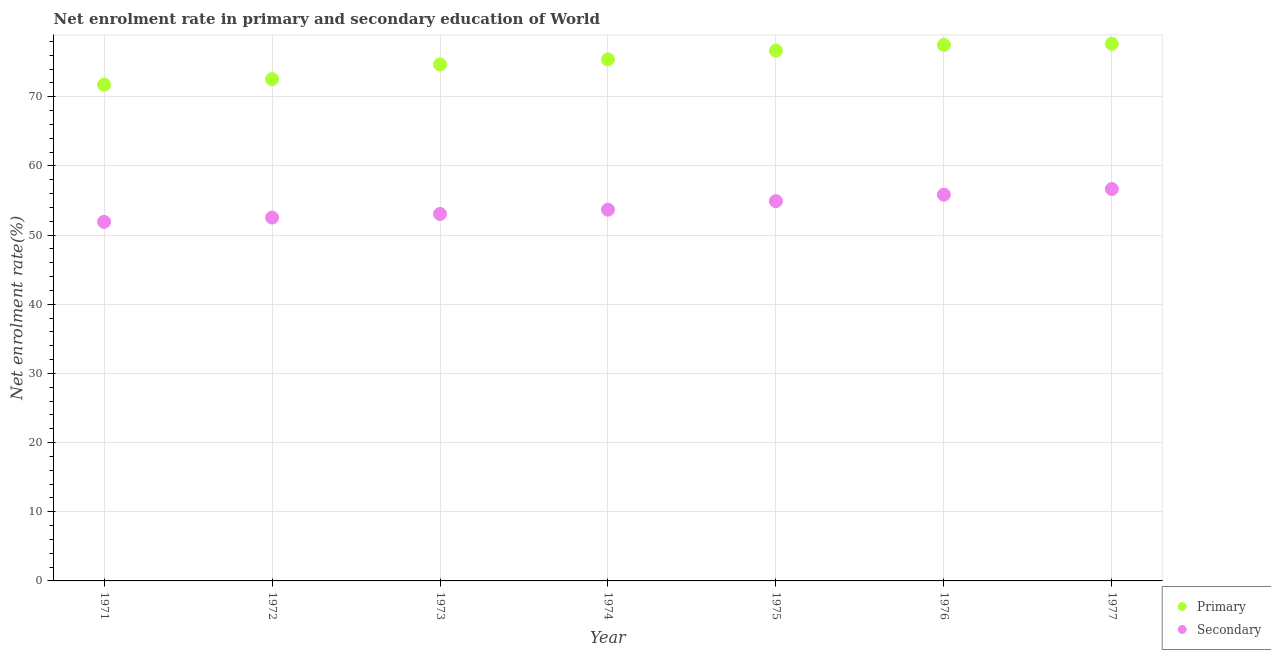Is the number of dotlines equal to the number of legend labels?
Offer a very short reply. Yes. What is the enrollment rate in secondary education in 1975?
Give a very brief answer. 54.9. Across all years, what is the maximum enrollment rate in primary education?
Your answer should be compact. 77.65. Across all years, what is the minimum enrollment rate in primary education?
Ensure brevity in your answer.  71.73. In which year was the enrollment rate in secondary education maximum?
Your response must be concise. 1977. In which year was the enrollment rate in secondary education minimum?
Make the answer very short. 1971. What is the total enrollment rate in primary education in the graph?
Provide a succinct answer. 526.11. What is the difference between the enrollment rate in secondary education in 1976 and that in 1977?
Provide a succinct answer. -0.82. What is the difference between the enrollment rate in secondary education in 1972 and the enrollment rate in primary education in 1974?
Ensure brevity in your answer.  -22.87. What is the average enrollment rate in primary education per year?
Offer a very short reply. 75.16. In the year 1977, what is the difference between the enrollment rate in primary education and enrollment rate in secondary education?
Provide a short and direct response. 21. What is the ratio of the enrollment rate in primary education in 1971 to that in 1977?
Ensure brevity in your answer.  0.92. Is the enrollment rate in secondary education in 1972 less than that in 1974?
Your answer should be very brief. Yes. Is the difference between the enrollment rate in secondary education in 1972 and 1975 greater than the difference between the enrollment rate in primary education in 1972 and 1975?
Make the answer very short. Yes. What is the difference between the highest and the second highest enrollment rate in primary education?
Give a very brief answer. 0.17. What is the difference between the highest and the lowest enrollment rate in secondary education?
Offer a very short reply. 4.74. In how many years, is the enrollment rate in secondary education greater than the average enrollment rate in secondary education taken over all years?
Make the answer very short. 3. Is the sum of the enrollment rate in primary education in 1972 and 1976 greater than the maximum enrollment rate in secondary education across all years?
Provide a succinct answer. Yes. Does the enrollment rate in secondary education monotonically increase over the years?
Keep it short and to the point. Yes. Is the enrollment rate in primary education strictly greater than the enrollment rate in secondary education over the years?
Ensure brevity in your answer.  Yes. Does the graph contain any zero values?
Your answer should be very brief. No. Does the graph contain grids?
Your response must be concise. Yes. How are the legend labels stacked?
Your answer should be very brief. Vertical. What is the title of the graph?
Give a very brief answer. Net enrolment rate in primary and secondary education of World. Does "Constant 2005 US$" appear as one of the legend labels in the graph?
Give a very brief answer. No. What is the label or title of the Y-axis?
Give a very brief answer. Net enrolment rate(%). What is the Net enrolment rate(%) of Primary in 1971?
Provide a succinct answer. 71.73. What is the Net enrolment rate(%) in Secondary in 1971?
Provide a succinct answer. 51.91. What is the Net enrolment rate(%) of Primary in 1972?
Provide a short and direct response. 72.54. What is the Net enrolment rate(%) in Secondary in 1972?
Ensure brevity in your answer.  52.52. What is the Net enrolment rate(%) in Primary in 1973?
Offer a terse response. 74.66. What is the Net enrolment rate(%) of Secondary in 1973?
Give a very brief answer. 53.05. What is the Net enrolment rate(%) of Primary in 1974?
Your answer should be compact. 75.39. What is the Net enrolment rate(%) of Secondary in 1974?
Make the answer very short. 53.67. What is the Net enrolment rate(%) in Primary in 1975?
Give a very brief answer. 76.66. What is the Net enrolment rate(%) of Secondary in 1975?
Provide a succinct answer. 54.9. What is the Net enrolment rate(%) of Primary in 1976?
Your answer should be very brief. 77.48. What is the Net enrolment rate(%) of Secondary in 1976?
Offer a terse response. 55.83. What is the Net enrolment rate(%) in Primary in 1977?
Provide a short and direct response. 77.65. What is the Net enrolment rate(%) in Secondary in 1977?
Offer a very short reply. 56.65. Across all years, what is the maximum Net enrolment rate(%) of Primary?
Offer a very short reply. 77.65. Across all years, what is the maximum Net enrolment rate(%) of Secondary?
Your answer should be compact. 56.65. Across all years, what is the minimum Net enrolment rate(%) of Primary?
Offer a very short reply. 71.73. Across all years, what is the minimum Net enrolment rate(%) in Secondary?
Give a very brief answer. 51.91. What is the total Net enrolment rate(%) of Primary in the graph?
Offer a terse response. 526.11. What is the total Net enrolment rate(%) of Secondary in the graph?
Your response must be concise. 378.53. What is the difference between the Net enrolment rate(%) of Primary in 1971 and that in 1972?
Keep it short and to the point. -0.81. What is the difference between the Net enrolment rate(%) of Secondary in 1971 and that in 1972?
Provide a succinct answer. -0.62. What is the difference between the Net enrolment rate(%) in Primary in 1971 and that in 1973?
Ensure brevity in your answer.  -2.93. What is the difference between the Net enrolment rate(%) of Secondary in 1971 and that in 1973?
Provide a succinct answer. -1.14. What is the difference between the Net enrolment rate(%) of Primary in 1971 and that in 1974?
Provide a short and direct response. -3.66. What is the difference between the Net enrolment rate(%) of Secondary in 1971 and that in 1974?
Offer a terse response. -1.76. What is the difference between the Net enrolment rate(%) in Primary in 1971 and that in 1975?
Your response must be concise. -4.93. What is the difference between the Net enrolment rate(%) in Secondary in 1971 and that in 1975?
Your answer should be very brief. -2.99. What is the difference between the Net enrolment rate(%) of Primary in 1971 and that in 1976?
Your response must be concise. -5.75. What is the difference between the Net enrolment rate(%) in Secondary in 1971 and that in 1976?
Your answer should be compact. -3.92. What is the difference between the Net enrolment rate(%) in Primary in 1971 and that in 1977?
Your answer should be compact. -5.92. What is the difference between the Net enrolment rate(%) in Secondary in 1971 and that in 1977?
Keep it short and to the point. -4.74. What is the difference between the Net enrolment rate(%) of Primary in 1972 and that in 1973?
Offer a terse response. -2.12. What is the difference between the Net enrolment rate(%) in Secondary in 1972 and that in 1973?
Offer a very short reply. -0.52. What is the difference between the Net enrolment rate(%) of Primary in 1972 and that in 1974?
Make the answer very short. -2.85. What is the difference between the Net enrolment rate(%) in Secondary in 1972 and that in 1974?
Your answer should be compact. -1.14. What is the difference between the Net enrolment rate(%) in Primary in 1972 and that in 1975?
Give a very brief answer. -4.12. What is the difference between the Net enrolment rate(%) in Secondary in 1972 and that in 1975?
Your answer should be very brief. -2.37. What is the difference between the Net enrolment rate(%) in Primary in 1972 and that in 1976?
Keep it short and to the point. -4.95. What is the difference between the Net enrolment rate(%) of Secondary in 1972 and that in 1976?
Give a very brief answer. -3.31. What is the difference between the Net enrolment rate(%) of Primary in 1972 and that in 1977?
Your response must be concise. -5.11. What is the difference between the Net enrolment rate(%) of Secondary in 1972 and that in 1977?
Provide a succinct answer. -4.13. What is the difference between the Net enrolment rate(%) in Primary in 1973 and that in 1974?
Give a very brief answer. -0.73. What is the difference between the Net enrolment rate(%) in Secondary in 1973 and that in 1974?
Offer a terse response. -0.62. What is the difference between the Net enrolment rate(%) of Primary in 1973 and that in 1975?
Offer a terse response. -2. What is the difference between the Net enrolment rate(%) of Secondary in 1973 and that in 1975?
Provide a short and direct response. -1.85. What is the difference between the Net enrolment rate(%) in Primary in 1973 and that in 1976?
Your answer should be compact. -2.82. What is the difference between the Net enrolment rate(%) of Secondary in 1973 and that in 1976?
Your answer should be compact. -2.78. What is the difference between the Net enrolment rate(%) in Primary in 1973 and that in 1977?
Offer a very short reply. -2.99. What is the difference between the Net enrolment rate(%) of Secondary in 1973 and that in 1977?
Provide a succinct answer. -3.6. What is the difference between the Net enrolment rate(%) of Primary in 1974 and that in 1975?
Offer a terse response. -1.27. What is the difference between the Net enrolment rate(%) in Secondary in 1974 and that in 1975?
Offer a terse response. -1.23. What is the difference between the Net enrolment rate(%) of Primary in 1974 and that in 1976?
Your response must be concise. -2.09. What is the difference between the Net enrolment rate(%) in Secondary in 1974 and that in 1976?
Offer a very short reply. -2.16. What is the difference between the Net enrolment rate(%) of Primary in 1974 and that in 1977?
Ensure brevity in your answer.  -2.26. What is the difference between the Net enrolment rate(%) in Secondary in 1974 and that in 1977?
Make the answer very short. -2.98. What is the difference between the Net enrolment rate(%) in Primary in 1975 and that in 1976?
Offer a very short reply. -0.82. What is the difference between the Net enrolment rate(%) of Secondary in 1975 and that in 1976?
Your answer should be compact. -0.93. What is the difference between the Net enrolment rate(%) in Primary in 1975 and that in 1977?
Provide a succinct answer. -0.99. What is the difference between the Net enrolment rate(%) of Secondary in 1975 and that in 1977?
Provide a short and direct response. -1.75. What is the difference between the Net enrolment rate(%) in Primary in 1976 and that in 1977?
Ensure brevity in your answer.  -0.17. What is the difference between the Net enrolment rate(%) in Secondary in 1976 and that in 1977?
Your answer should be compact. -0.82. What is the difference between the Net enrolment rate(%) in Primary in 1971 and the Net enrolment rate(%) in Secondary in 1972?
Offer a very short reply. 19.21. What is the difference between the Net enrolment rate(%) of Primary in 1971 and the Net enrolment rate(%) of Secondary in 1973?
Offer a terse response. 18.68. What is the difference between the Net enrolment rate(%) of Primary in 1971 and the Net enrolment rate(%) of Secondary in 1974?
Your answer should be compact. 18.06. What is the difference between the Net enrolment rate(%) in Primary in 1971 and the Net enrolment rate(%) in Secondary in 1975?
Keep it short and to the point. 16.83. What is the difference between the Net enrolment rate(%) of Primary in 1971 and the Net enrolment rate(%) of Secondary in 1976?
Your response must be concise. 15.9. What is the difference between the Net enrolment rate(%) of Primary in 1971 and the Net enrolment rate(%) of Secondary in 1977?
Offer a terse response. 15.08. What is the difference between the Net enrolment rate(%) in Primary in 1972 and the Net enrolment rate(%) in Secondary in 1973?
Your response must be concise. 19.49. What is the difference between the Net enrolment rate(%) of Primary in 1972 and the Net enrolment rate(%) of Secondary in 1974?
Make the answer very short. 18.87. What is the difference between the Net enrolment rate(%) in Primary in 1972 and the Net enrolment rate(%) in Secondary in 1975?
Keep it short and to the point. 17.64. What is the difference between the Net enrolment rate(%) in Primary in 1972 and the Net enrolment rate(%) in Secondary in 1976?
Offer a terse response. 16.71. What is the difference between the Net enrolment rate(%) of Primary in 1972 and the Net enrolment rate(%) of Secondary in 1977?
Provide a succinct answer. 15.89. What is the difference between the Net enrolment rate(%) in Primary in 1973 and the Net enrolment rate(%) in Secondary in 1974?
Provide a short and direct response. 20.99. What is the difference between the Net enrolment rate(%) in Primary in 1973 and the Net enrolment rate(%) in Secondary in 1975?
Your response must be concise. 19.76. What is the difference between the Net enrolment rate(%) of Primary in 1973 and the Net enrolment rate(%) of Secondary in 1976?
Your answer should be compact. 18.83. What is the difference between the Net enrolment rate(%) in Primary in 1973 and the Net enrolment rate(%) in Secondary in 1977?
Provide a succinct answer. 18.01. What is the difference between the Net enrolment rate(%) of Primary in 1974 and the Net enrolment rate(%) of Secondary in 1975?
Make the answer very short. 20.49. What is the difference between the Net enrolment rate(%) of Primary in 1974 and the Net enrolment rate(%) of Secondary in 1976?
Keep it short and to the point. 19.56. What is the difference between the Net enrolment rate(%) in Primary in 1974 and the Net enrolment rate(%) in Secondary in 1977?
Keep it short and to the point. 18.74. What is the difference between the Net enrolment rate(%) of Primary in 1975 and the Net enrolment rate(%) of Secondary in 1976?
Keep it short and to the point. 20.83. What is the difference between the Net enrolment rate(%) in Primary in 1975 and the Net enrolment rate(%) in Secondary in 1977?
Keep it short and to the point. 20.01. What is the difference between the Net enrolment rate(%) in Primary in 1976 and the Net enrolment rate(%) in Secondary in 1977?
Offer a very short reply. 20.83. What is the average Net enrolment rate(%) in Primary per year?
Make the answer very short. 75.16. What is the average Net enrolment rate(%) in Secondary per year?
Provide a succinct answer. 54.08. In the year 1971, what is the difference between the Net enrolment rate(%) of Primary and Net enrolment rate(%) of Secondary?
Your answer should be very brief. 19.82. In the year 1972, what is the difference between the Net enrolment rate(%) in Primary and Net enrolment rate(%) in Secondary?
Your answer should be compact. 20.01. In the year 1973, what is the difference between the Net enrolment rate(%) of Primary and Net enrolment rate(%) of Secondary?
Offer a very short reply. 21.61. In the year 1974, what is the difference between the Net enrolment rate(%) of Primary and Net enrolment rate(%) of Secondary?
Make the answer very short. 21.72. In the year 1975, what is the difference between the Net enrolment rate(%) in Primary and Net enrolment rate(%) in Secondary?
Your response must be concise. 21.76. In the year 1976, what is the difference between the Net enrolment rate(%) of Primary and Net enrolment rate(%) of Secondary?
Your response must be concise. 21.65. In the year 1977, what is the difference between the Net enrolment rate(%) of Primary and Net enrolment rate(%) of Secondary?
Your answer should be compact. 21. What is the ratio of the Net enrolment rate(%) in Primary in 1971 to that in 1972?
Give a very brief answer. 0.99. What is the ratio of the Net enrolment rate(%) in Secondary in 1971 to that in 1972?
Offer a very short reply. 0.99. What is the ratio of the Net enrolment rate(%) of Primary in 1971 to that in 1973?
Keep it short and to the point. 0.96. What is the ratio of the Net enrolment rate(%) in Secondary in 1971 to that in 1973?
Offer a very short reply. 0.98. What is the ratio of the Net enrolment rate(%) in Primary in 1971 to that in 1974?
Ensure brevity in your answer.  0.95. What is the ratio of the Net enrolment rate(%) of Secondary in 1971 to that in 1974?
Keep it short and to the point. 0.97. What is the ratio of the Net enrolment rate(%) in Primary in 1971 to that in 1975?
Provide a succinct answer. 0.94. What is the ratio of the Net enrolment rate(%) of Secondary in 1971 to that in 1975?
Keep it short and to the point. 0.95. What is the ratio of the Net enrolment rate(%) of Primary in 1971 to that in 1976?
Give a very brief answer. 0.93. What is the ratio of the Net enrolment rate(%) of Secondary in 1971 to that in 1976?
Offer a terse response. 0.93. What is the ratio of the Net enrolment rate(%) of Primary in 1971 to that in 1977?
Make the answer very short. 0.92. What is the ratio of the Net enrolment rate(%) of Secondary in 1971 to that in 1977?
Your response must be concise. 0.92. What is the ratio of the Net enrolment rate(%) in Primary in 1972 to that in 1973?
Offer a terse response. 0.97. What is the ratio of the Net enrolment rate(%) in Secondary in 1972 to that in 1973?
Offer a terse response. 0.99. What is the ratio of the Net enrolment rate(%) in Primary in 1972 to that in 1974?
Your response must be concise. 0.96. What is the ratio of the Net enrolment rate(%) of Secondary in 1972 to that in 1974?
Provide a succinct answer. 0.98. What is the ratio of the Net enrolment rate(%) in Primary in 1972 to that in 1975?
Keep it short and to the point. 0.95. What is the ratio of the Net enrolment rate(%) of Secondary in 1972 to that in 1975?
Your response must be concise. 0.96. What is the ratio of the Net enrolment rate(%) of Primary in 1972 to that in 1976?
Your answer should be very brief. 0.94. What is the ratio of the Net enrolment rate(%) of Secondary in 1972 to that in 1976?
Your response must be concise. 0.94. What is the ratio of the Net enrolment rate(%) in Primary in 1972 to that in 1977?
Your answer should be very brief. 0.93. What is the ratio of the Net enrolment rate(%) of Secondary in 1972 to that in 1977?
Your answer should be compact. 0.93. What is the ratio of the Net enrolment rate(%) of Primary in 1973 to that in 1974?
Your response must be concise. 0.99. What is the ratio of the Net enrolment rate(%) of Secondary in 1973 to that in 1974?
Your answer should be very brief. 0.99. What is the ratio of the Net enrolment rate(%) in Primary in 1973 to that in 1975?
Offer a very short reply. 0.97. What is the ratio of the Net enrolment rate(%) in Secondary in 1973 to that in 1975?
Keep it short and to the point. 0.97. What is the ratio of the Net enrolment rate(%) of Primary in 1973 to that in 1976?
Make the answer very short. 0.96. What is the ratio of the Net enrolment rate(%) in Secondary in 1973 to that in 1976?
Your answer should be compact. 0.95. What is the ratio of the Net enrolment rate(%) of Primary in 1973 to that in 1977?
Provide a succinct answer. 0.96. What is the ratio of the Net enrolment rate(%) in Secondary in 1973 to that in 1977?
Give a very brief answer. 0.94. What is the ratio of the Net enrolment rate(%) of Primary in 1974 to that in 1975?
Ensure brevity in your answer.  0.98. What is the ratio of the Net enrolment rate(%) of Secondary in 1974 to that in 1975?
Ensure brevity in your answer.  0.98. What is the ratio of the Net enrolment rate(%) in Secondary in 1974 to that in 1976?
Your answer should be very brief. 0.96. What is the ratio of the Net enrolment rate(%) of Primary in 1974 to that in 1977?
Ensure brevity in your answer.  0.97. What is the ratio of the Net enrolment rate(%) in Secondary in 1975 to that in 1976?
Provide a succinct answer. 0.98. What is the ratio of the Net enrolment rate(%) of Primary in 1975 to that in 1977?
Your response must be concise. 0.99. What is the ratio of the Net enrolment rate(%) in Secondary in 1975 to that in 1977?
Provide a short and direct response. 0.97. What is the ratio of the Net enrolment rate(%) of Secondary in 1976 to that in 1977?
Your response must be concise. 0.99. What is the difference between the highest and the second highest Net enrolment rate(%) in Primary?
Your answer should be compact. 0.17. What is the difference between the highest and the second highest Net enrolment rate(%) of Secondary?
Offer a very short reply. 0.82. What is the difference between the highest and the lowest Net enrolment rate(%) in Primary?
Make the answer very short. 5.92. What is the difference between the highest and the lowest Net enrolment rate(%) of Secondary?
Give a very brief answer. 4.74. 